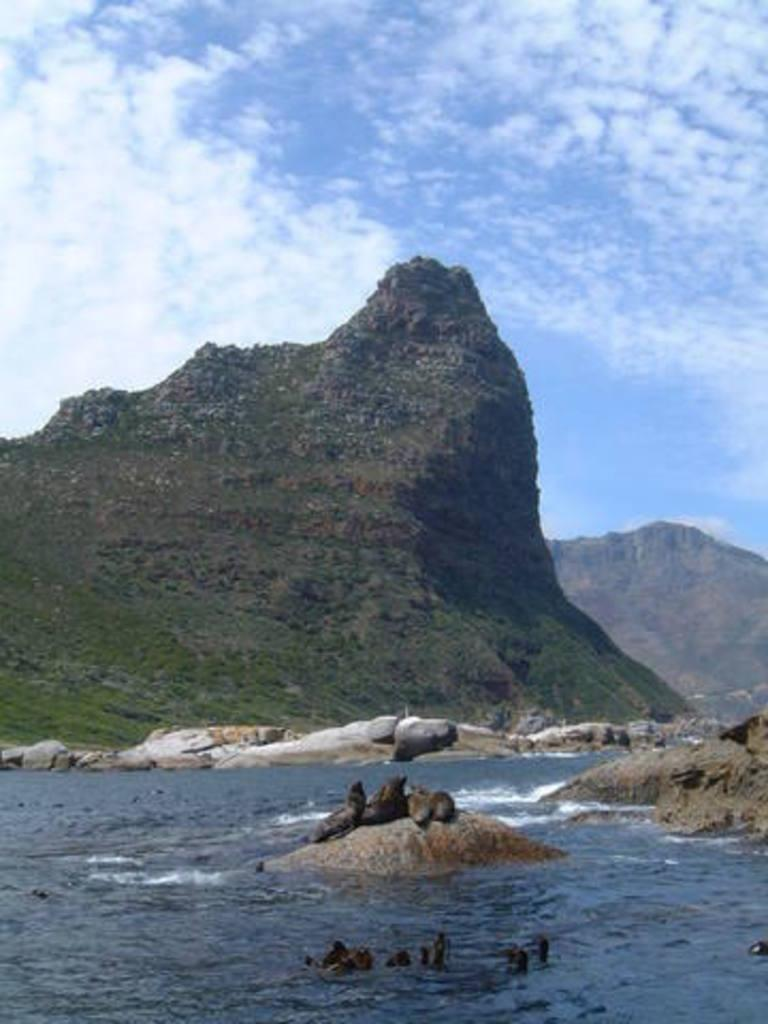What animals are standing on a rock in the image? There are seals standing on a rock in the image. What are the seals doing in the water? The seals are swimming in the water. What can be seen in the background of the image? There is a hill visible in the background of the image. What type of vegetation covers the ground in the image? The ground is covered with grass. What is the condition of the sky in the image? The sky is clear in the image. What type of yarn is being used to create the seals' swimming patterns in the image? There is no yarn present in the image, and the seals' swimming patterns are not created by any yarn. 